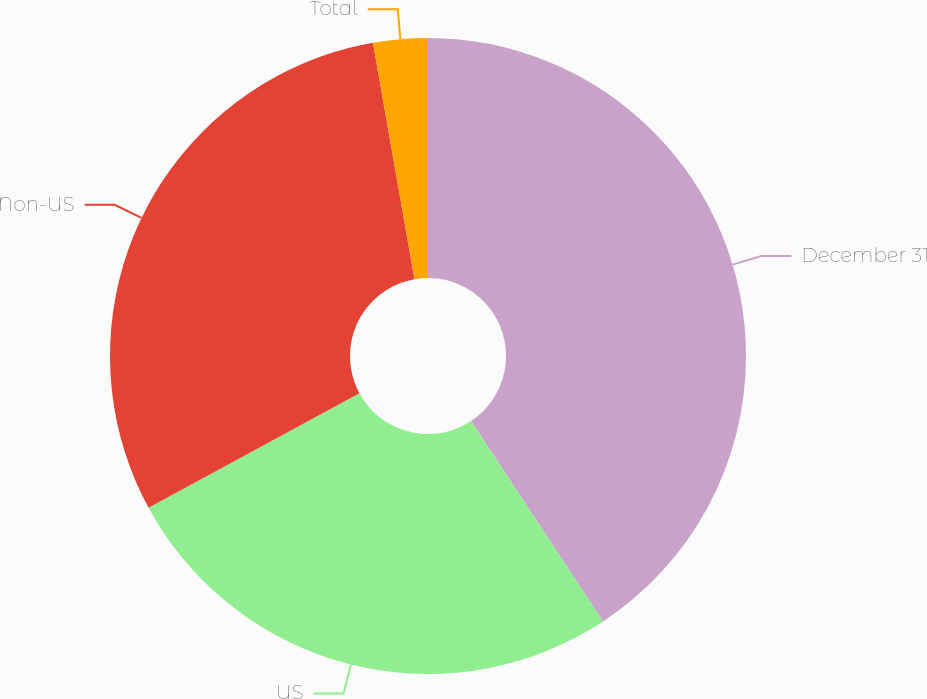<chart> <loc_0><loc_0><loc_500><loc_500><pie_chart><fcel>December 31<fcel>US<fcel>Non-US<fcel>Total<nl><fcel>40.72%<fcel>26.36%<fcel>30.15%<fcel>2.77%<nl></chart> 